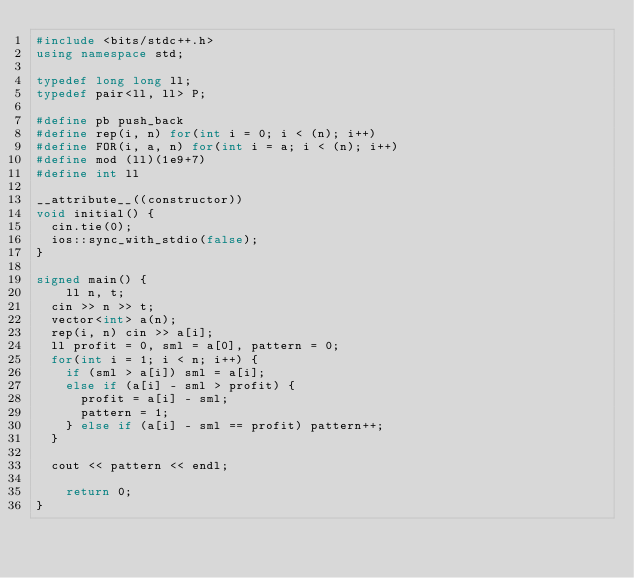<code> <loc_0><loc_0><loc_500><loc_500><_C++_>#include <bits/stdc++.h>
using namespace std;

typedef long long ll;
typedef pair<ll, ll> P;

#define pb push_back
#define rep(i, n) for(int i = 0; i < (n); i++)
#define FOR(i, a, n) for(int i = a; i < (n); i++)
#define mod (ll)(1e9+7)
#define int ll

__attribute__((constructor))
void initial() {
  cin.tie(0);
  ios::sync_with_stdio(false);
}

signed main() {
	ll n, t;
  cin >> n >> t;
  vector<int> a(n);
  rep(i, n) cin >> a[i];
  ll profit = 0, sml = a[0], pattern = 0;
  for(int i = 1; i < n; i++) {
    if (sml > a[i]) sml = a[i];
    else if (a[i] - sml > profit) {
      profit = a[i] - sml;
      pattern = 1;
    } else if (a[i] - sml == profit) pattern++;
  }

  cout << pattern << endl;

	return 0;
}</code> 